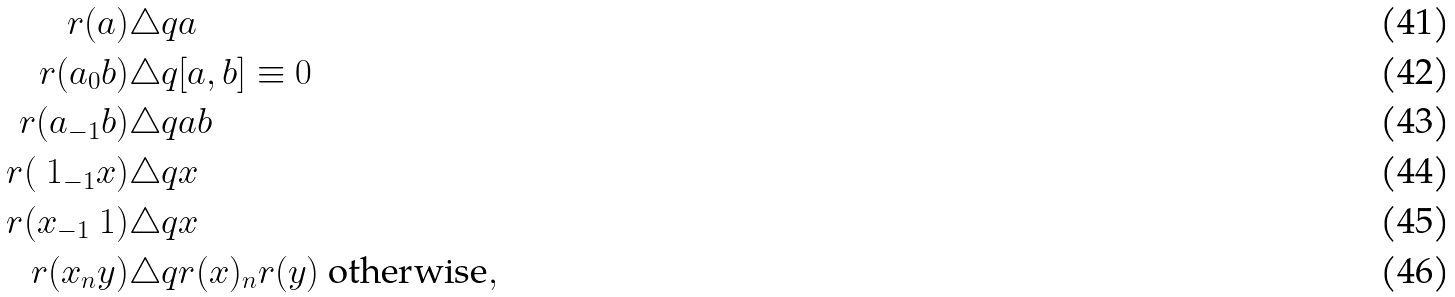<formula> <loc_0><loc_0><loc_500><loc_500>r ( a ) & \triangle q a \\ r ( a _ { 0 } b ) & \triangle q [ a , b ] \equiv 0 \\ r ( a _ { - 1 } b ) & \triangle q a b \\ r ( \ 1 _ { - 1 } x ) & \triangle q x \\ r ( x _ { - 1 } \ 1 ) & \triangle q x \\ r ( x _ { n } y ) & \triangle q r ( x ) _ { n } r ( y ) \text { otherwise} ,</formula> 